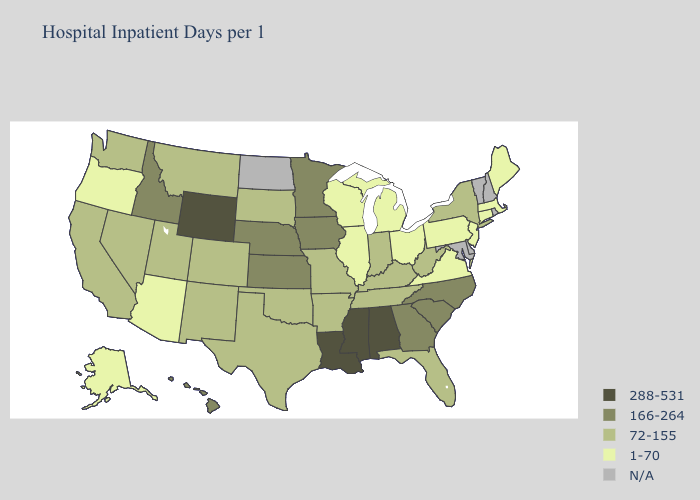What is the lowest value in states that border South Carolina?
Short answer required. 166-264. What is the lowest value in the South?
Write a very short answer. 1-70. What is the highest value in states that border Oregon?
Concise answer only. 166-264. Which states have the lowest value in the MidWest?
Quick response, please. Illinois, Michigan, Ohio, Wisconsin. What is the value of California?
Answer briefly. 72-155. Does Maine have the highest value in the USA?
Give a very brief answer. No. Name the states that have a value in the range N/A?
Write a very short answer. Delaware, Maryland, New Hampshire, North Dakota, Rhode Island, Vermont. Does Georgia have the highest value in the USA?
Answer briefly. No. Name the states that have a value in the range 288-531?
Write a very short answer. Alabama, Louisiana, Mississippi, Wyoming. What is the lowest value in the West?
Short answer required. 1-70. Does Montana have the highest value in the USA?
Concise answer only. No. Among the states that border Arkansas , does Mississippi have the lowest value?
Give a very brief answer. No. Among the states that border New Mexico , does Colorado have the lowest value?
Quick response, please. No. 